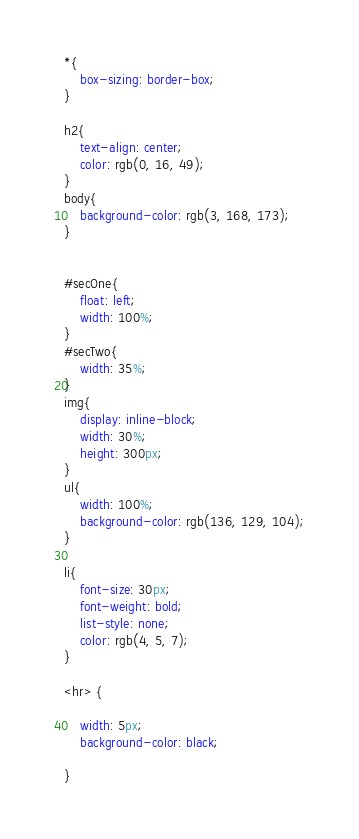Convert code to text. <code><loc_0><loc_0><loc_500><loc_500><_CSS_>*{
    box-sizing: border-box;
}

h2{
    text-align: center;
    color: rgb(0, 16, 49);
}
body{
    background-color: rgb(3, 168, 173);
}


#secOne{
    float: left;
    width: 100%;
}   
#secTwo{
    width: 35%;
}
img{
    display: inline-block;
    width: 30%;
    height: 300px;
}
ul{
    width: 100%;
    background-color: rgb(136, 129, 104);
}

li{
    font-size: 30px;
    font-weight: bold;
    list-style: none;
    color: rgb(4, 5, 7);
}

<hr> {

    width: 5px;
    background-color: black;
    
}</code> 